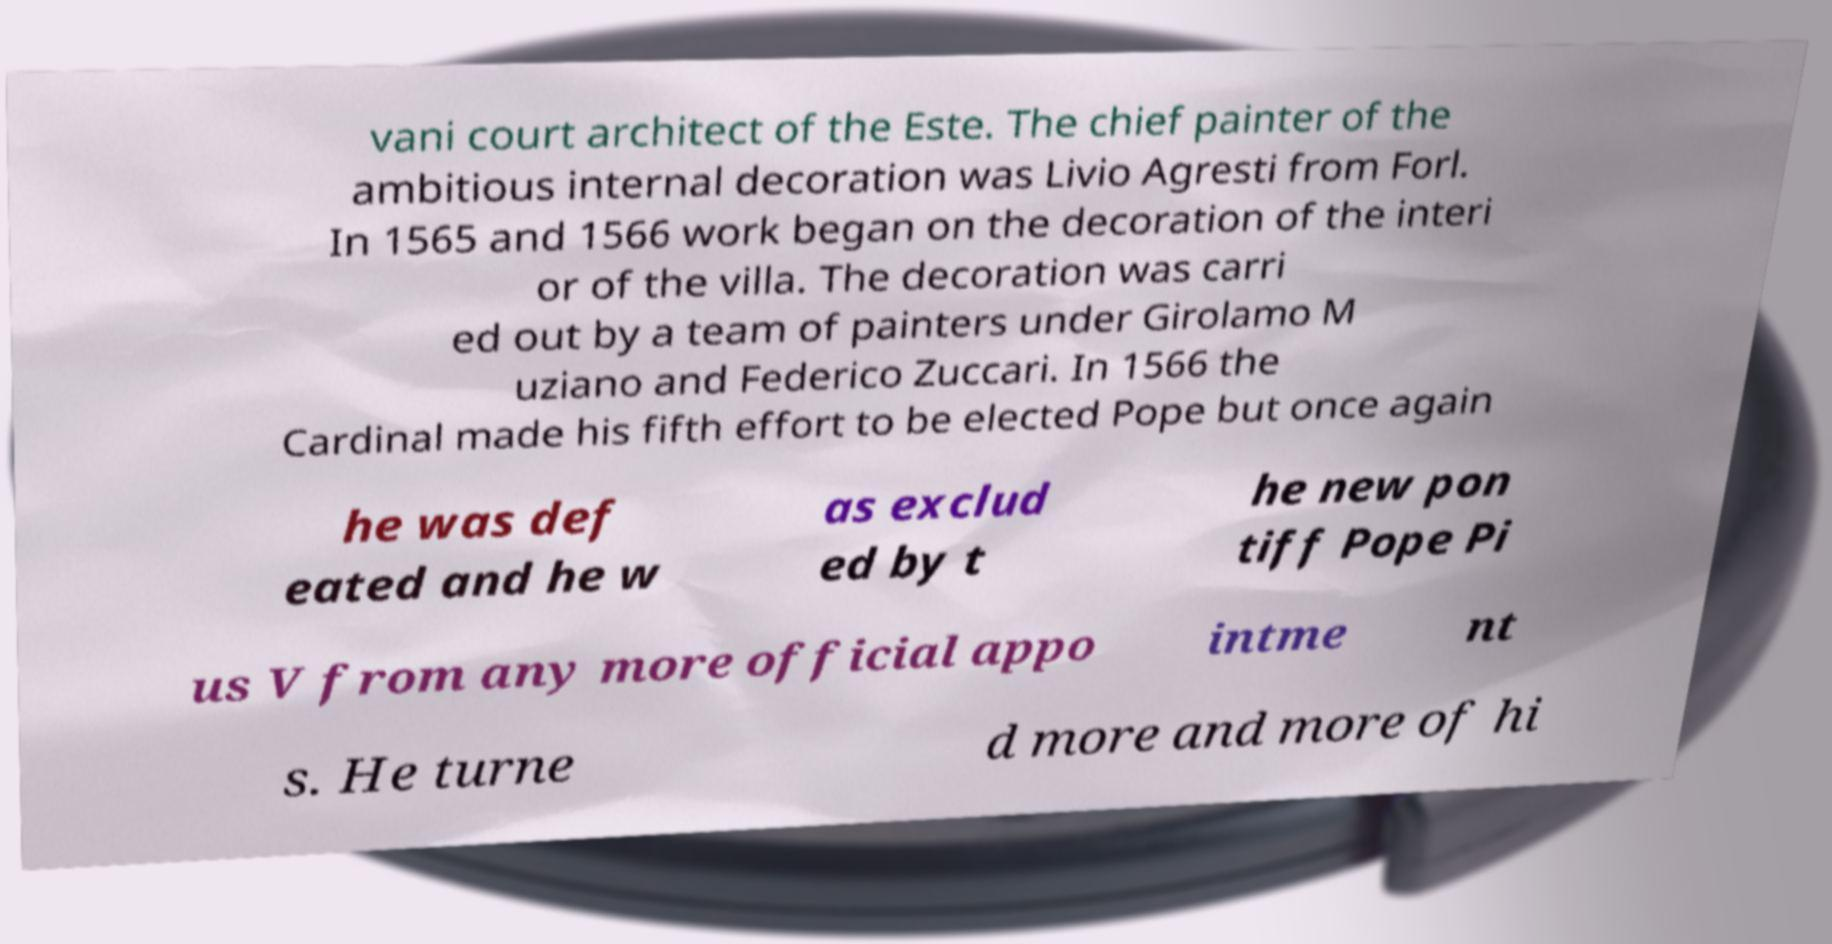What messages or text are displayed in this image? I need them in a readable, typed format. vani court architect of the Este. The chief painter of the ambitious internal decoration was Livio Agresti from Forl. In 1565 and 1566 work began on the decoration of the interi or of the villa. The decoration was carri ed out by a team of painters under Girolamo M uziano and Federico Zuccari. In 1566 the Cardinal made his fifth effort to be elected Pope but once again he was def eated and he w as exclud ed by t he new pon tiff Pope Pi us V from any more official appo intme nt s. He turne d more and more of hi 